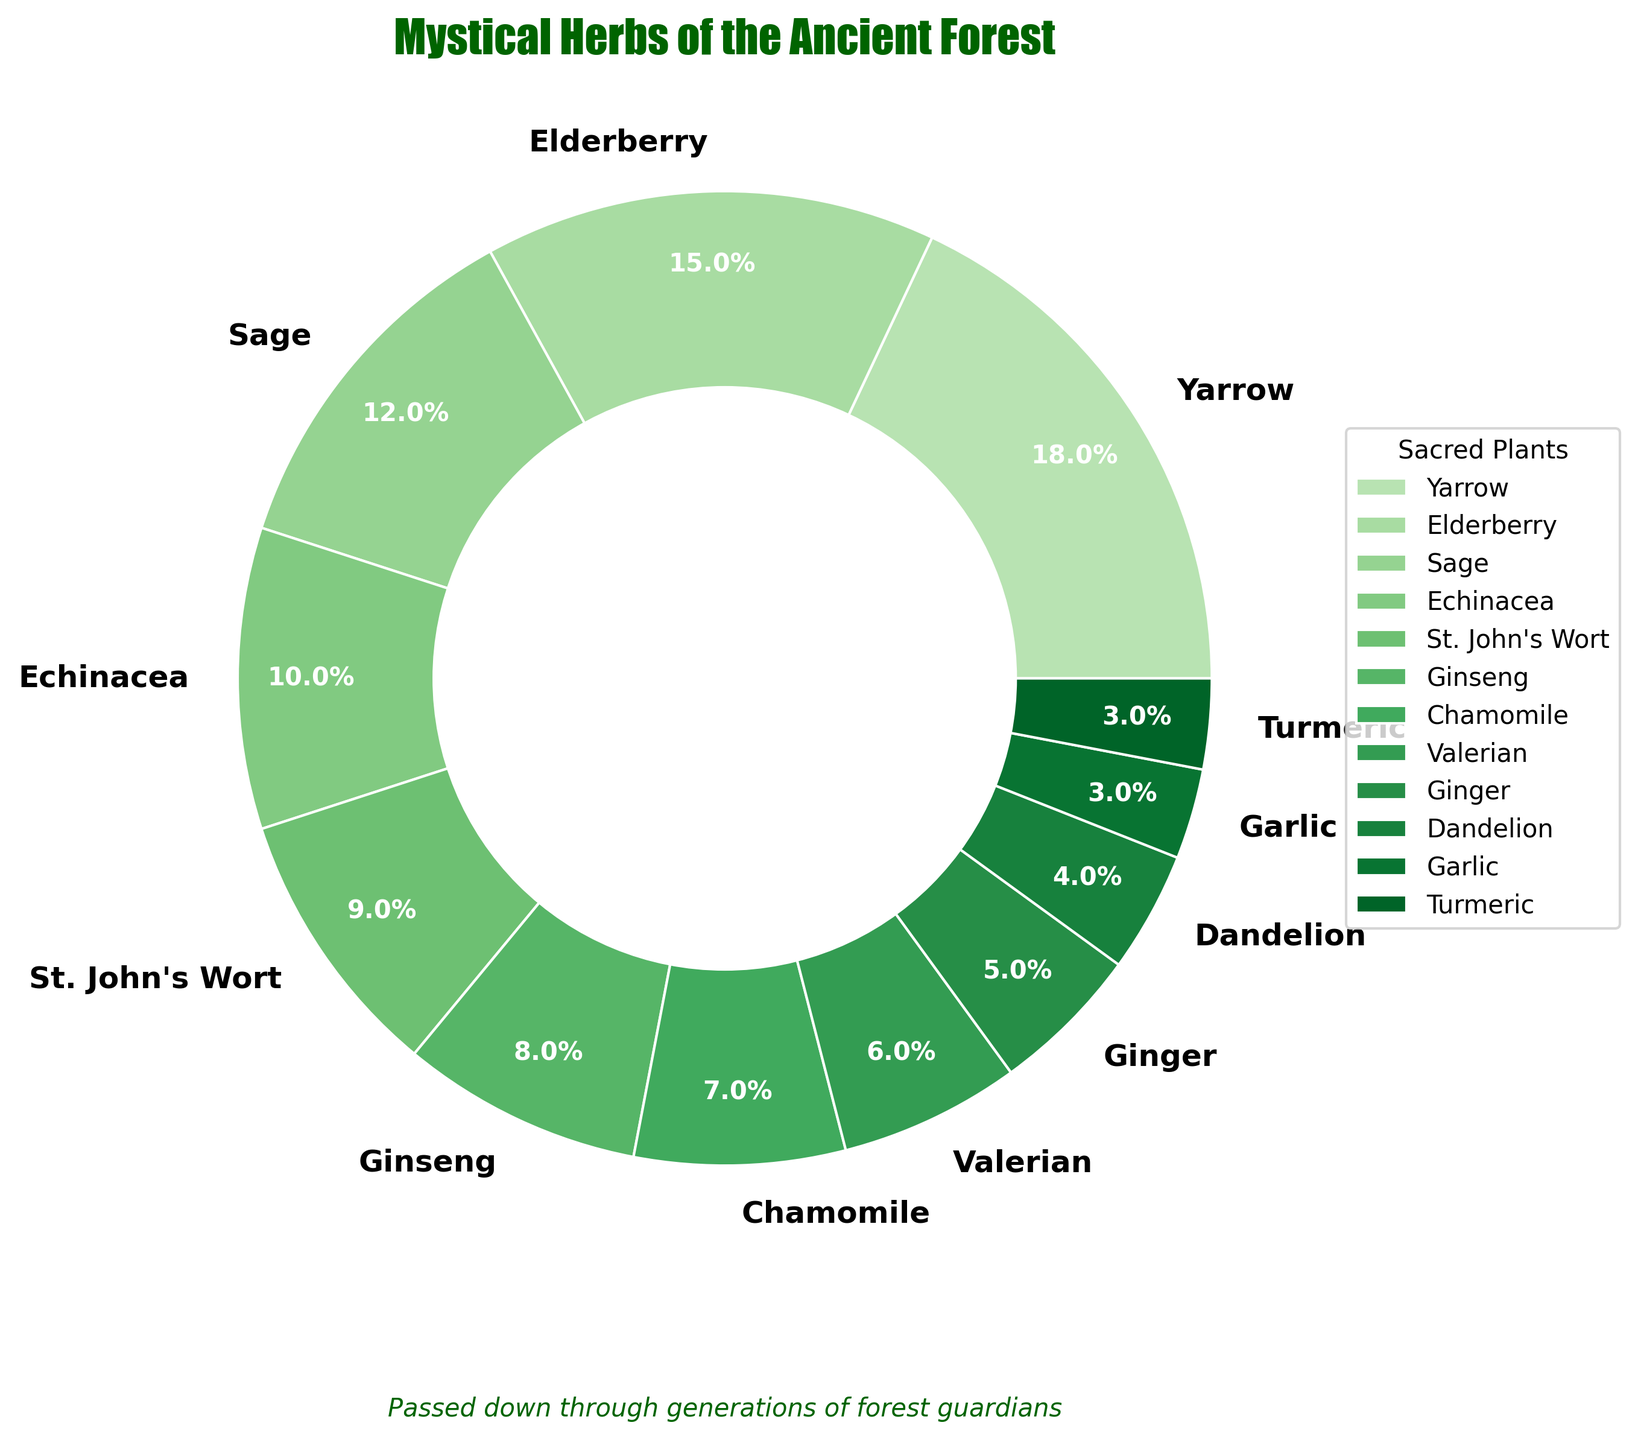Which plant has the highest percentage in traditional folklore remedies? The plant with the largest slice in the pie chart represents the highest percentage. In this case, it is the Yarrow plant.
Answer: Yarrow Which plant has a higher percentage: Elderberry or Chamomile? Compare the slices labeled 'Elderberry' and 'Chamomile'. Elderberry has 15% while Chamomile has 7%. Since 15% is greater than 7%, Elderberry has a higher percentage.
Answer: Elderberry What is the combined percentage of Ginseng and Garlic? Add the percentages of Ginseng and Garlic. Ginseng has 8% and Garlic has 3%, so 8% + 3% = 11%.
Answer: 11% Which plants together make up approximately 25% of the total? Check the slices whose combined percentages approximate 25%. Yarrow is 18% and Elderberry is 15%, so Yarrow 18% + Sage 12% = 30%, which is close to 25%.
Answer: Yarrow and Sage How much larger is the percentage of Echinacea compared to Ginger? Subtract the percentage of Ginger from that of Echinacea. Echinacea is 10% and Ginger is 5%, so 10% - 5% = 5%.
Answer: 5% Which has a larger percentage: Valerian or St. John's Wort? Compare the slices labeled 'Valerian' and 'St. John's Wort'. Valerian has 6% while St. John's Wort has 9%. Since 9% is greater than 6%, St. John's Wort has a higher percentage.
Answer: St. John's Wort What is the percentage difference between the plant with the most usage and the plant with the least usage? The largest percentage is Yarrow at 18% and the smallest is Garlic and Turmeric each at 3%. The difference is 18% - 3% = 15%.
Answer: 15% Which three plants contribute the lowest percentages to the total? Identify the three smallest slices: Garlic, Turmeric (both at 3%), and Dandelion (4%).
Answer: Garlic, Turmeric, and Dandelion If you combine the percentages of the four least used plants, what do you get? Add the percentages of the four smallest slices: Garlic (3%), Turmeric (3%), Dandelion (4%), and Ginger (5%). So, 3% + 3% + 4% + 5% = 15%.
Answer: 15% Which plant has a percentage equal to the median value of all plant percentages? List all the percentages and find the middle value. Percentages: 18%, 15%, 12%, 10%, 9%, 8%, 7%, 6%, 5%, 4%, 3%, 3%. The median value in ascending order list: 3%, 3%, 4%, 5%, 6%, 7%, 8%, 9%, 10%, 12%, 15%, 18% is 8%, which corresponds to Ginseng.
Answer: Ginseng 